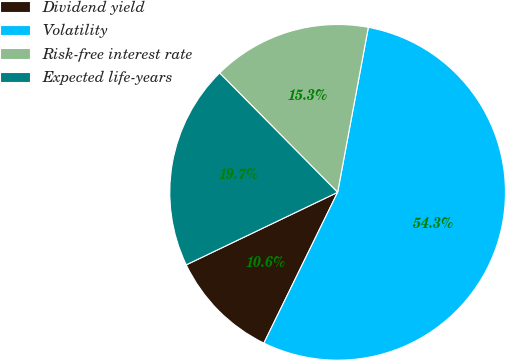Convert chart to OTSL. <chart><loc_0><loc_0><loc_500><loc_500><pie_chart><fcel>Dividend yield<fcel>Volatility<fcel>Risk-free interest rate<fcel>Expected life-years<nl><fcel>10.65%<fcel>54.31%<fcel>15.34%<fcel>19.7%<nl></chart> 